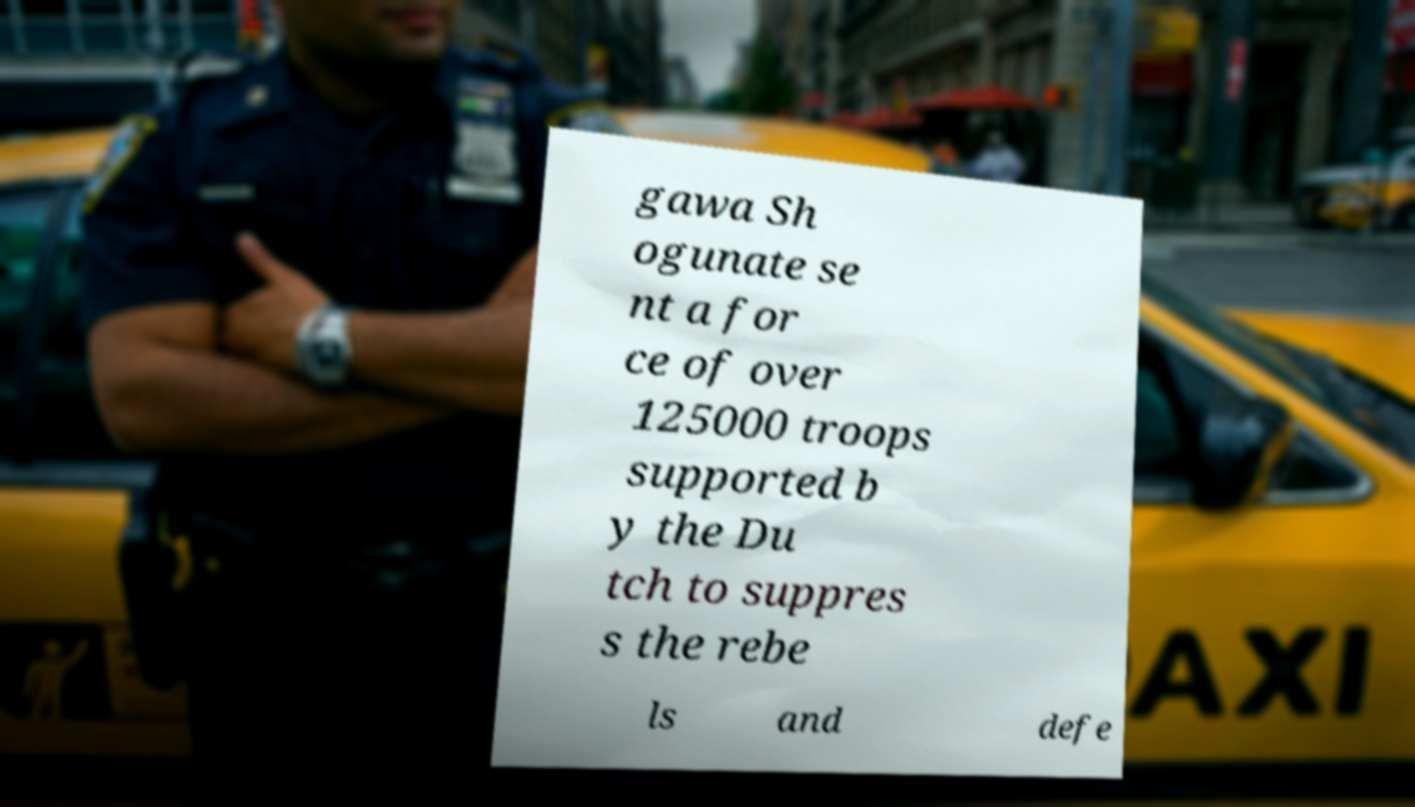Could you assist in decoding the text presented in this image and type it out clearly? gawa Sh ogunate se nt a for ce of over 125000 troops supported b y the Du tch to suppres s the rebe ls and defe 